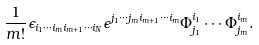Convert formula to latex. <formula><loc_0><loc_0><loc_500><loc_500>\frac { 1 } { m ! } \epsilon _ { i _ { 1 } \cdots i _ { m } i _ { m + 1 } \cdots i _ { N } } \epsilon ^ { j _ { 1 } \cdots j _ { m } i _ { m + 1 } \cdots i _ { m } } \Phi ^ { i _ { 1 } } _ { j _ { 1 } } \cdots \Phi ^ { i _ { m } } _ { j _ { m } } .</formula> 